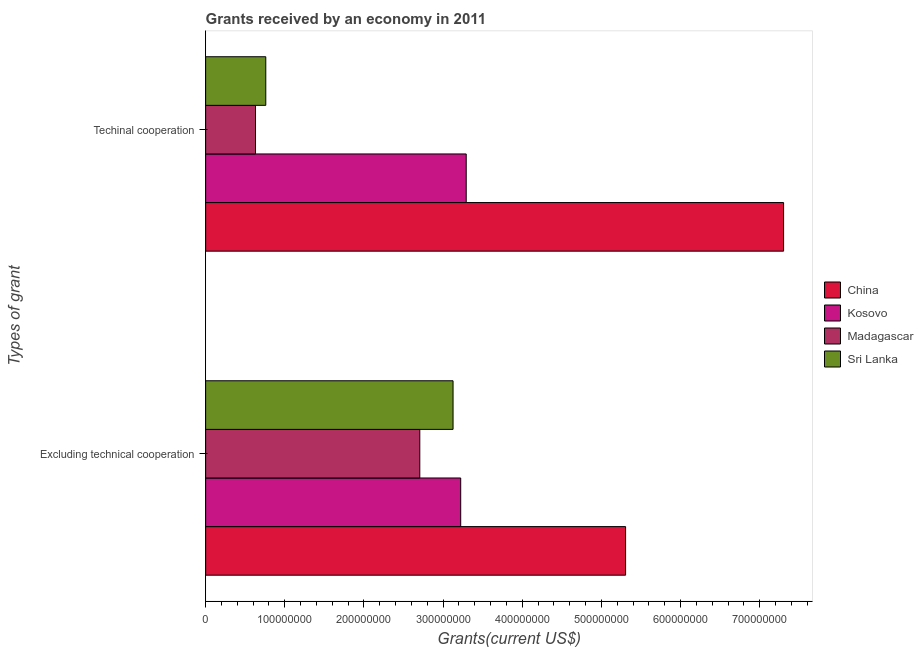How many groups of bars are there?
Offer a very short reply. 2. How many bars are there on the 2nd tick from the top?
Offer a very short reply. 4. What is the label of the 1st group of bars from the top?
Keep it short and to the point. Techinal cooperation. What is the amount of grants received(including technical cooperation) in Kosovo?
Provide a short and direct response. 3.29e+08. Across all countries, what is the maximum amount of grants received(excluding technical cooperation)?
Give a very brief answer. 5.30e+08. Across all countries, what is the minimum amount of grants received(including technical cooperation)?
Provide a succinct answer. 6.30e+07. In which country was the amount of grants received(including technical cooperation) minimum?
Provide a short and direct response. Madagascar. What is the total amount of grants received(including technical cooperation) in the graph?
Keep it short and to the point. 1.20e+09. What is the difference between the amount of grants received(including technical cooperation) in China and that in Madagascar?
Your answer should be compact. 6.67e+08. What is the difference between the amount of grants received(including technical cooperation) in Sri Lanka and the amount of grants received(excluding technical cooperation) in Madagascar?
Give a very brief answer. -1.95e+08. What is the average amount of grants received(excluding technical cooperation) per country?
Offer a very short reply. 3.59e+08. What is the difference between the amount of grants received(including technical cooperation) and amount of grants received(excluding technical cooperation) in Kosovo?
Provide a short and direct response. 6.96e+06. In how many countries, is the amount of grants received(excluding technical cooperation) greater than 740000000 US$?
Keep it short and to the point. 0. What is the ratio of the amount of grants received(excluding technical cooperation) in Madagascar to that in Sri Lanka?
Your answer should be compact. 0.87. In how many countries, is the amount of grants received(including technical cooperation) greater than the average amount of grants received(including technical cooperation) taken over all countries?
Give a very brief answer. 2. What does the 2nd bar from the top in Excluding technical cooperation represents?
Your response must be concise. Madagascar. What does the 2nd bar from the bottom in Techinal cooperation represents?
Give a very brief answer. Kosovo. What is the difference between two consecutive major ticks on the X-axis?
Provide a succinct answer. 1.00e+08. Does the graph contain any zero values?
Make the answer very short. No. How many legend labels are there?
Offer a very short reply. 4. What is the title of the graph?
Your answer should be compact. Grants received by an economy in 2011. What is the label or title of the X-axis?
Keep it short and to the point. Grants(current US$). What is the label or title of the Y-axis?
Your response must be concise. Types of grant. What is the Grants(current US$) in China in Excluding technical cooperation?
Offer a terse response. 5.30e+08. What is the Grants(current US$) in Kosovo in Excluding technical cooperation?
Your answer should be compact. 3.22e+08. What is the Grants(current US$) of Madagascar in Excluding technical cooperation?
Provide a succinct answer. 2.71e+08. What is the Grants(current US$) in Sri Lanka in Excluding technical cooperation?
Provide a succinct answer. 3.13e+08. What is the Grants(current US$) of China in Techinal cooperation?
Offer a terse response. 7.30e+08. What is the Grants(current US$) of Kosovo in Techinal cooperation?
Ensure brevity in your answer.  3.29e+08. What is the Grants(current US$) in Madagascar in Techinal cooperation?
Keep it short and to the point. 6.30e+07. What is the Grants(current US$) of Sri Lanka in Techinal cooperation?
Keep it short and to the point. 7.60e+07. Across all Types of grant, what is the maximum Grants(current US$) of China?
Offer a very short reply. 7.30e+08. Across all Types of grant, what is the maximum Grants(current US$) in Kosovo?
Offer a very short reply. 3.29e+08. Across all Types of grant, what is the maximum Grants(current US$) in Madagascar?
Your response must be concise. 2.71e+08. Across all Types of grant, what is the maximum Grants(current US$) in Sri Lanka?
Your response must be concise. 3.13e+08. Across all Types of grant, what is the minimum Grants(current US$) in China?
Provide a succinct answer. 5.30e+08. Across all Types of grant, what is the minimum Grants(current US$) in Kosovo?
Provide a succinct answer. 3.22e+08. Across all Types of grant, what is the minimum Grants(current US$) in Madagascar?
Your answer should be very brief. 6.30e+07. Across all Types of grant, what is the minimum Grants(current US$) of Sri Lanka?
Offer a very short reply. 7.60e+07. What is the total Grants(current US$) in China in the graph?
Make the answer very short. 1.26e+09. What is the total Grants(current US$) of Kosovo in the graph?
Offer a very short reply. 6.51e+08. What is the total Grants(current US$) in Madagascar in the graph?
Provide a short and direct response. 3.34e+08. What is the total Grants(current US$) in Sri Lanka in the graph?
Your answer should be very brief. 3.88e+08. What is the difference between the Grants(current US$) of China in Excluding technical cooperation and that in Techinal cooperation?
Provide a succinct answer. -2.00e+08. What is the difference between the Grants(current US$) of Kosovo in Excluding technical cooperation and that in Techinal cooperation?
Your response must be concise. -6.96e+06. What is the difference between the Grants(current US$) of Madagascar in Excluding technical cooperation and that in Techinal cooperation?
Provide a short and direct response. 2.08e+08. What is the difference between the Grants(current US$) of Sri Lanka in Excluding technical cooperation and that in Techinal cooperation?
Make the answer very short. 2.37e+08. What is the difference between the Grants(current US$) in China in Excluding technical cooperation and the Grants(current US$) in Kosovo in Techinal cooperation?
Keep it short and to the point. 2.01e+08. What is the difference between the Grants(current US$) in China in Excluding technical cooperation and the Grants(current US$) in Madagascar in Techinal cooperation?
Offer a terse response. 4.67e+08. What is the difference between the Grants(current US$) of China in Excluding technical cooperation and the Grants(current US$) of Sri Lanka in Techinal cooperation?
Keep it short and to the point. 4.54e+08. What is the difference between the Grants(current US$) in Kosovo in Excluding technical cooperation and the Grants(current US$) in Madagascar in Techinal cooperation?
Your answer should be very brief. 2.59e+08. What is the difference between the Grants(current US$) of Kosovo in Excluding technical cooperation and the Grants(current US$) of Sri Lanka in Techinal cooperation?
Make the answer very short. 2.46e+08. What is the difference between the Grants(current US$) in Madagascar in Excluding technical cooperation and the Grants(current US$) in Sri Lanka in Techinal cooperation?
Offer a terse response. 1.95e+08. What is the average Grants(current US$) in China per Types of grant?
Your answer should be very brief. 6.30e+08. What is the average Grants(current US$) of Kosovo per Types of grant?
Ensure brevity in your answer.  3.26e+08. What is the average Grants(current US$) in Madagascar per Types of grant?
Give a very brief answer. 1.67e+08. What is the average Grants(current US$) of Sri Lanka per Types of grant?
Offer a terse response. 1.94e+08. What is the difference between the Grants(current US$) in China and Grants(current US$) in Kosovo in Excluding technical cooperation?
Keep it short and to the point. 2.08e+08. What is the difference between the Grants(current US$) of China and Grants(current US$) of Madagascar in Excluding technical cooperation?
Provide a succinct answer. 2.60e+08. What is the difference between the Grants(current US$) in China and Grants(current US$) in Sri Lanka in Excluding technical cooperation?
Give a very brief answer. 2.18e+08. What is the difference between the Grants(current US$) of Kosovo and Grants(current US$) of Madagascar in Excluding technical cooperation?
Your answer should be compact. 5.17e+07. What is the difference between the Grants(current US$) in Kosovo and Grants(current US$) in Sri Lanka in Excluding technical cooperation?
Ensure brevity in your answer.  9.66e+06. What is the difference between the Grants(current US$) of Madagascar and Grants(current US$) of Sri Lanka in Excluding technical cooperation?
Make the answer very short. -4.20e+07. What is the difference between the Grants(current US$) of China and Grants(current US$) of Kosovo in Techinal cooperation?
Offer a terse response. 4.01e+08. What is the difference between the Grants(current US$) of China and Grants(current US$) of Madagascar in Techinal cooperation?
Keep it short and to the point. 6.67e+08. What is the difference between the Grants(current US$) in China and Grants(current US$) in Sri Lanka in Techinal cooperation?
Provide a short and direct response. 6.54e+08. What is the difference between the Grants(current US$) in Kosovo and Grants(current US$) in Madagascar in Techinal cooperation?
Ensure brevity in your answer.  2.66e+08. What is the difference between the Grants(current US$) in Kosovo and Grants(current US$) in Sri Lanka in Techinal cooperation?
Your answer should be very brief. 2.53e+08. What is the difference between the Grants(current US$) in Madagascar and Grants(current US$) in Sri Lanka in Techinal cooperation?
Keep it short and to the point. -1.30e+07. What is the ratio of the Grants(current US$) of China in Excluding technical cooperation to that in Techinal cooperation?
Your answer should be compact. 0.73. What is the ratio of the Grants(current US$) of Kosovo in Excluding technical cooperation to that in Techinal cooperation?
Your answer should be compact. 0.98. What is the ratio of the Grants(current US$) of Madagascar in Excluding technical cooperation to that in Techinal cooperation?
Give a very brief answer. 4.29. What is the ratio of the Grants(current US$) in Sri Lanka in Excluding technical cooperation to that in Techinal cooperation?
Keep it short and to the point. 4.11. What is the difference between the highest and the second highest Grants(current US$) in China?
Ensure brevity in your answer.  2.00e+08. What is the difference between the highest and the second highest Grants(current US$) in Kosovo?
Your answer should be compact. 6.96e+06. What is the difference between the highest and the second highest Grants(current US$) in Madagascar?
Offer a very short reply. 2.08e+08. What is the difference between the highest and the second highest Grants(current US$) of Sri Lanka?
Your answer should be very brief. 2.37e+08. What is the difference between the highest and the lowest Grants(current US$) of China?
Ensure brevity in your answer.  2.00e+08. What is the difference between the highest and the lowest Grants(current US$) in Kosovo?
Provide a short and direct response. 6.96e+06. What is the difference between the highest and the lowest Grants(current US$) in Madagascar?
Keep it short and to the point. 2.08e+08. What is the difference between the highest and the lowest Grants(current US$) of Sri Lanka?
Your response must be concise. 2.37e+08. 